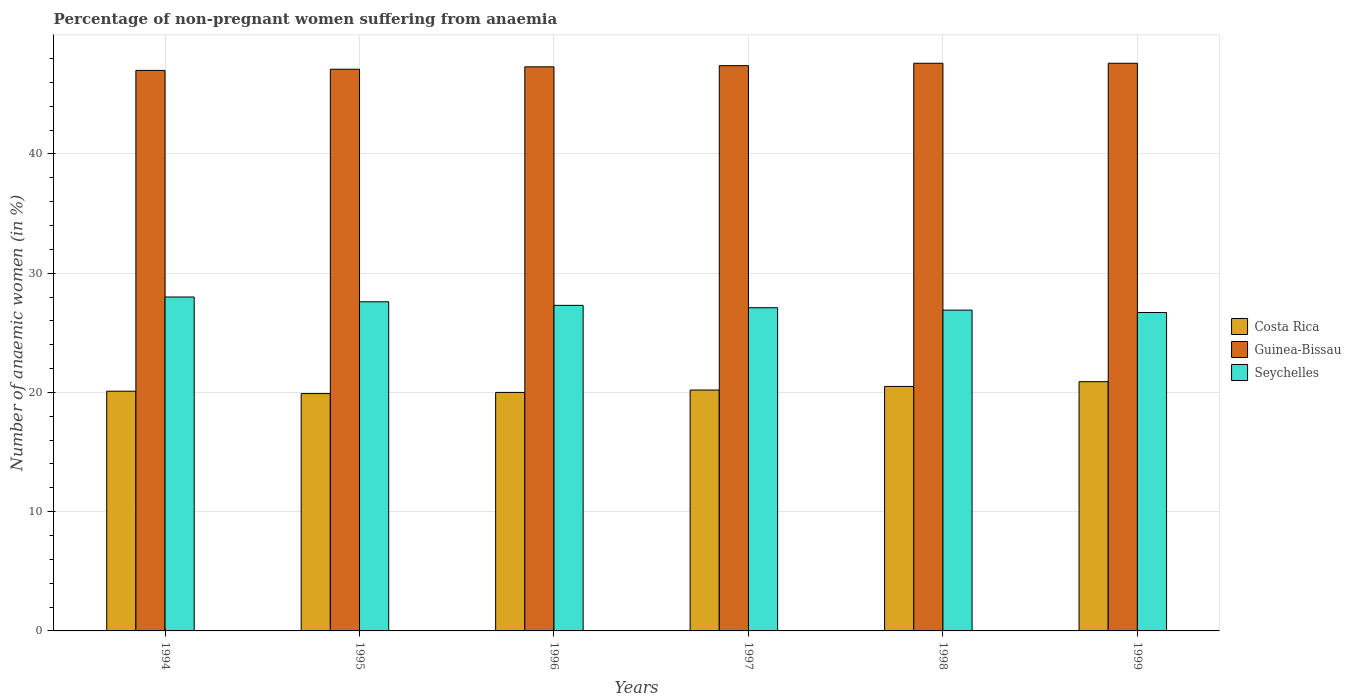How many groups of bars are there?
Provide a short and direct response. 6. Are the number of bars per tick equal to the number of legend labels?
Your answer should be compact. Yes. Are the number of bars on each tick of the X-axis equal?
Make the answer very short. Yes. How many bars are there on the 1st tick from the right?
Offer a terse response. 3. In how many cases, is the number of bars for a given year not equal to the number of legend labels?
Your answer should be very brief. 0. What is the percentage of non-pregnant women suffering from anaemia in Guinea-Bissau in 1997?
Your answer should be very brief. 47.4. Across all years, what is the maximum percentage of non-pregnant women suffering from anaemia in Costa Rica?
Offer a terse response. 20.9. Across all years, what is the minimum percentage of non-pregnant women suffering from anaemia in Seychelles?
Your answer should be very brief. 26.7. What is the total percentage of non-pregnant women suffering from anaemia in Guinea-Bissau in the graph?
Offer a very short reply. 284. What is the difference between the percentage of non-pregnant women suffering from anaemia in Costa Rica in 1999 and the percentage of non-pregnant women suffering from anaemia in Guinea-Bissau in 1996?
Make the answer very short. -26.4. What is the average percentage of non-pregnant women suffering from anaemia in Guinea-Bissau per year?
Make the answer very short. 47.33. In the year 1997, what is the difference between the percentage of non-pregnant women suffering from anaemia in Seychelles and percentage of non-pregnant women suffering from anaemia in Guinea-Bissau?
Provide a short and direct response. -20.3. What is the ratio of the percentage of non-pregnant women suffering from anaemia in Guinea-Bissau in 1996 to that in 1999?
Offer a terse response. 0.99. Is the percentage of non-pregnant women suffering from anaemia in Seychelles in 1995 less than that in 1998?
Your response must be concise. No. Is the difference between the percentage of non-pregnant women suffering from anaemia in Seychelles in 1995 and 1999 greater than the difference between the percentage of non-pregnant women suffering from anaemia in Guinea-Bissau in 1995 and 1999?
Provide a short and direct response. Yes. What is the difference between the highest and the lowest percentage of non-pregnant women suffering from anaemia in Costa Rica?
Offer a very short reply. 1. What does the 3rd bar from the left in 1999 represents?
Provide a succinct answer. Seychelles. What does the 2nd bar from the right in 1995 represents?
Make the answer very short. Guinea-Bissau. How many bars are there?
Make the answer very short. 18. Are the values on the major ticks of Y-axis written in scientific E-notation?
Provide a short and direct response. No. How are the legend labels stacked?
Your answer should be very brief. Vertical. What is the title of the graph?
Provide a short and direct response. Percentage of non-pregnant women suffering from anaemia. What is the label or title of the X-axis?
Keep it short and to the point. Years. What is the label or title of the Y-axis?
Provide a short and direct response. Number of anaemic women (in %). What is the Number of anaemic women (in %) of Costa Rica in 1994?
Your answer should be compact. 20.1. What is the Number of anaemic women (in %) in Guinea-Bissau in 1994?
Your answer should be compact. 47. What is the Number of anaemic women (in %) of Seychelles in 1994?
Your response must be concise. 28. What is the Number of anaemic women (in %) of Guinea-Bissau in 1995?
Provide a succinct answer. 47.1. What is the Number of anaemic women (in %) in Seychelles in 1995?
Keep it short and to the point. 27.6. What is the Number of anaemic women (in %) in Costa Rica in 1996?
Keep it short and to the point. 20. What is the Number of anaemic women (in %) of Guinea-Bissau in 1996?
Give a very brief answer. 47.3. What is the Number of anaemic women (in %) in Seychelles in 1996?
Make the answer very short. 27.3. What is the Number of anaemic women (in %) of Costa Rica in 1997?
Keep it short and to the point. 20.2. What is the Number of anaemic women (in %) of Guinea-Bissau in 1997?
Give a very brief answer. 47.4. What is the Number of anaemic women (in %) of Seychelles in 1997?
Your response must be concise. 27.1. What is the Number of anaemic women (in %) in Costa Rica in 1998?
Your answer should be very brief. 20.5. What is the Number of anaemic women (in %) of Guinea-Bissau in 1998?
Offer a terse response. 47.6. What is the Number of anaemic women (in %) of Seychelles in 1998?
Your answer should be compact. 26.9. What is the Number of anaemic women (in %) in Costa Rica in 1999?
Your response must be concise. 20.9. What is the Number of anaemic women (in %) in Guinea-Bissau in 1999?
Ensure brevity in your answer.  47.6. What is the Number of anaemic women (in %) of Seychelles in 1999?
Your answer should be compact. 26.7. Across all years, what is the maximum Number of anaemic women (in %) in Costa Rica?
Offer a terse response. 20.9. Across all years, what is the maximum Number of anaemic women (in %) in Guinea-Bissau?
Offer a very short reply. 47.6. Across all years, what is the minimum Number of anaemic women (in %) of Guinea-Bissau?
Provide a succinct answer. 47. Across all years, what is the minimum Number of anaemic women (in %) of Seychelles?
Give a very brief answer. 26.7. What is the total Number of anaemic women (in %) in Costa Rica in the graph?
Give a very brief answer. 121.6. What is the total Number of anaemic women (in %) of Guinea-Bissau in the graph?
Your response must be concise. 284. What is the total Number of anaemic women (in %) in Seychelles in the graph?
Your response must be concise. 163.6. What is the difference between the Number of anaemic women (in %) in Guinea-Bissau in 1994 and that in 1995?
Your answer should be compact. -0.1. What is the difference between the Number of anaemic women (in %) in Seychelles in 1994 and that in 1995?
Your response must be concise. 0.4. What is the difference between the Number of anaemic women (in %) in Costa Rica in 1994 and that in 1996?
Offer a very short reply. 0.1. What is the difference between the Number of anaemic women (in %) in Seychelles in 1994 and that in 1997?
Offer a terse response. 0.9. What is the difference between the Number of anaemic women (in %) in Costa Rica in 1994 and that in 1999?
Your response must be concise. -0.8. What is the difference between the Number of anaemic women (in %) in Guinea-Bissau in 1994 and that in 1999?
Give a very brief answer. -0.6. What is the difference between the Number of anaemic women (in %) of Costa Rica in 1995 and that in 1996?
Keep it short and to the point. -0.1. What is the difference between the Number of anaemic women (in %) of Guinea-Bissau in 1995 and that in 1996?
Your response must be concise. -0.2. What is the difference between the Number of anaemic women (in %) in Costa Rica in 1995 and that in 1997?
Your answer should be compact. -0.3. What is the difference between the Number of anaemic women (in %) in Guinea-Bissau in 1995 and that in 1997?
Offer a very short reply. -0.3. What is the difference between the Number of anaemic women (in %) of Seychelles in 1995 and that in 1997?
Offer a terse response. 0.5. What is the difference between the Number of anaemic women (in %) in Guinea-Bissau in 1995 and that in 1998?
Keep it short and to the point. -0.5. What is the difference between the Number of anaemic women (in %) in Costa Rica in 1995 and that in 1999?
Provide a succinct answer. -1. What is the difference between the Number of anaemic women (in %) in Guinea-Bissau in 1995 and that in 1999?
Provide a succinct answer. -0.5. What is the difference between the Number of anaemic women (in %) in Guinea-Bissau in 1996 and that in 1997?
Offer a very short reply. -0.1. What is the difference between the Number of anaemic women (in %) in Guinea-Bissau in 1996 and that in 1998?
Offer a very short reply. -0.3. What is the difference between the Number of anaemic women (in %) of Seychelles in 1996 and that in 1998?
Your answer should be very brief. 0.4. What is the difference between the Number of anaemic women (in %) of Seychelles in 1996 and that in 1999?
Provide a short and direct response. 0.6. What is the difference between the Number of anaemic women (in %) of Costa Rica in 1997 and that in 1998?
Provide a short and direct response. -0.3. What is the difference between the Number of anaemic women (in %) of Guinea-Bissau in 1997 and that in 1998?
Offer a terse response. -0.2. What is the difference between the Number of anaemic women (in %) of Seychelles in 1997 and that in 1998?
Keep it short and to the point. 0.2. What is the difference between the Number of anaemic women (in %) of Costa Rica in 1997 and that in 1999?
Your answer should be very brief. -0.7. What is the difference between the Number of anaemic women (in %) in Seychelles in 1997 and that in 1999?
Provide a short and direct response. 0.4. What is the difference between the Number of anaemic women (in %) in Costa Rica in 1998 and that in 1999?
Make the answer very short. -0.4. What is the difference between the Number of anaemic women (in %) of Seychelles in 1998 and that in 1999?
Your answer should be compact. 0.2. What is the difference between the Number of anaemic women (in %) in Guinea-Bissau in 1994 and the Number of anaemic women (in %) in Seychelles in 1995?
Provide a short and direct response. 19.4. What is the difference between the Number of anaemic women (in %) of Costa Rica in 1994 and the Number of anaemic women (in %) of Guinea-Bissau in 1996?
Provide a succinct answer. -27.2. What is the difference between the Number of anaemic women (in %) in Costa Rica in 1994 and the Number of anaemic women (in %) in Seychelles in 1996?
Make the answer very short. -7.2. What is the difference between the Number of anaemic women (in %) in Costa Rica in 1994 and the Number of anaemic women (in %) in Guinea-Bissau in 1997?
Your response must be concise. -27.3. What is the difference between the Number of anaemic women (in %) of Costa Rica in 1994 and the Number of anaemic women (in %) of Seychelles in 1997?
Your answer should be very brief. -7. What is the difference between the Number of anaemic women (in %) of Guinea-Bissau in 1994 and the Number of anaemic women (in %) of Seychelles in 1997?
Your response must be concise. 19.9. What is the difference between the Number of anaemic women (in %) in Costa Rica in 1994 and the Number of anaemic women (in %) in Guinea-Bissau in 1998?
Your response must be concise. -27.5. What is the difference between the Number of anaemic women (in %) in Guinea-Bissau in 1994 and the Number of anaemic women (in %) in Seychelles in 1998?
Provide a succinct answer. 20.1. What is the difference between the Number of anaemic women (in %) of Costa Rica in 1994 and the Number of anaemic women (in %) of Guinea-Bissau in 1999?
Offer a terse response. -27.5. What is the difference between the Number of anaemic women (in %) of Guinea-Bissau in 1994 and the Number of anaemic women (in %) of Seychelles in 1999?
Give a very brief answer. 20.3. What is the difference between the Number of anaemic women (in %) of Costa Rica in 1995 and the Number of anaemic women (in %) of Guinea-Bissau in 1996?
Offer a very short reply. -27.4. What is the difference between the Number of anaemic women (in %) of Guinea-Bissau in 1995 and the Number of anaemic women (in %) of Seychelles in 1996?
Your response must be concise. 19.8. What is the difference between the Number of anaemic women (in %) in Costa Rica in 1995 and the Number of anaemic women (in %) in Guinea-Bissau in 1997?
Your answer should be very brief. -27.5. What is the difference between the Number of anaemic women (in %) in Costa Rica in 1995 and the Number of anaemic women (in %) in Guinea-Bissau in 1998?
Keep it short and to the point. -27.7. What is the difference between the Number of anaemic women (in %) in Guinea-Bissau in 1995 and the Number of anaemic women (in %) in Seychelles in 1998?
Provide a short and direct response. 20.2. What is the difference between the Number of anaemic women (in %) in Costa Rica in 1995 and the Number of anaemic women (in %) in Guinea-Bissau in 1999?
Your answer should be very brief. -27.7. What is the difference between the Number of anaemic women (in %) in Guinea-Bissau in 1995 and the Number of anaemic women (in %) in Seychelles in 1999?
Your response must be concise. 20.4. What is the difference between the Number of anaemic women (in %) in Costa Rica in 1996 and the Number of anaemic women (in %) in Guinea-Bissau in 1997?
Provide a succinct answer. -27.4. What is the difference between the Number of anaemic women (in %) of Costa Rica in 1996 and the Number of anaemic women (in %) of Seychelles in 1997?
Make the answer very short. -7.1. What is the difference between the Number of anaemic women (in %) in Guinea-Bissau in 1996 and the Number of anaemic women (in %) in Seychelles in 1997?
Your answer should be very brief. 20.2. What is the difference between the Number of anaemic women (in %) in Costa Rica in 1996 and the Number of anaemic women (in %) in Guinea-Bissau in 1998?
Your answer should be very brief. -27.6. What is the difference between the Number of anaemic women (in %) in Costa Rica in 1996 and the Number of anaemic women (in %) in Seychelles in 1998?
Offer a very short reply. -6.9. What is the difference between the Number of anaemic women (in %) of Guinea-Bissau in 1996 and the Number of anaemic women (in %) of Seychelles in 1998?
Ensure brevity in your answer.  20.4. What is the difference between the Number of anaemic women (in %) in Costa Rica in 1996 and the Number of anaemic women (in %) in Guinea-Bissau in 1999?
Your answer should be very brief. -27.6. What is the difference between the Number of anaemic women (in %) of Costa Rica in 1996 and the Number of anaemic women (in %) of Seychelles in 1999?
Provide a succinct answer. -6.7. What is the difference between the Number of anaemic women (in %) of Guinea-Bissau in 1996 and the Number of anaemic women (in %) of Seychelles in 1999?
Your response must be concise. 20.6. What is the difference between the Number of anaemic women (in %) in Costa Rica in 1997 and the Number of anaemic women (in %) in Guinea-Bissau in 1998?
Keep it short and to the point. -27.4. What is the difference between the Number of anaemic women (in %) of Costa Rica in 1997 and the Number of anaemic women (in %) of Seychelles in 1998?
Make the answer very short. -6.7. What is the difference between the Number of anaemic women (in %) of Costa Rica in 1997 and the Number of anaemic women (in %) of Guinea-Bissau in 1999?
Offer a very short reply. -27.4. What is the difference between the Number of anaemic women (in %) in Guinea-Bissau in 1997 and the Number of anaemic women (in %) in Seychelles in 1999?
Keep it short and to the point. 20.7. What is the difference between the Number of anaemic women (in %) of Costa Rica in 1998 and the Number of anaemic women (in %) of Guinea-Bissau in 1999?
Your answer should be very brief. -27.1. What is the difference between the Number of anaemic women (in %) in Guinea-Bissau in 1998 and the Number of anaemic women (in %) in Seychelles in 1999?
Keep it short and to the point. 20.9. What is the average Number of anaemic women (in %) in Costa Rica per year?
Provide a succinct answer. 20.27. What is the average Number of anaemic women (in %) of Guinea-Bissau per year?
Give a very brief answer. 47.33. What is the average Number of anaemic women (in %) of Seychelles per year?
Provide a succinct answer. 27.27. In the year 1994, what is the difference between the Number of anaemic women (in %) of Costa Rica and Number of anaemic women (in %) of Guinea-Bissau?
Provide a succinct answer. -26.9. In the year 1995, what is the difference between the Number of anaemic women (in %) of Costa Rica and Number of anaemic women (in %) of Guinea-Bissau?
Keep it short and to the point. -27.2. In the year 1996, what is the difference between the Number of anaemic women (in %) in Costa Rica and Number of anaemic women (in %) in Guinea-Bissau?
Ensure brevity in your answer.  -27.3. In the year 1997, what is the difference between the Number of anaemic women (in %) of Costa Rica and Number of anaemic women (in %) of Guinea-Bissau?
Provide a succinct answer. -27.2. In the year 1997, what is the difference between the Number of anaemic women (in %) of Guinea-Bissau and Number of anaemic women (in %) of Seychelles?
Keep it short and to the point. 20.3. In the year 1998, what is the difference between the Number of anaemic women (in %) of Costa Rica and Number of anaemic women (in %) of Guinea-Bissau?
Your answer should be compact. -27.1. In the year 1998, what is the difference between the Number of anaemic women (in %) in Guinea-Bissau and Number of anaemic women (in %) in Seychelles?
Ensure brevity in your answer.  20.7. In the year 1999, what is the difference between the Number of anaemic women (in %) in Costa Rica and Number of anaemic women (in %) in Guinea-Bissau?
Make the answer very short. -26.7. In the year 1999, what is the difference between the Number of anaemic women (in %) of Costa Rica and Number of anaemic women (in %) of Seychelles?
Your answer should be very brief. -5.8. In the year 1999, what is the difference between the Number of anaemic women (in %) of Guinea-Bissau and Number of anaemic women (in %) of Seychelles?
Give a very brief answer. 20.9. What is the ratio of the Number of anaemic women (in %) of Guinea-Bissau in 1994 to that in 1995?
Your response must be concise. 1. What is the ratio of the Number of anaemic women (in %) of Seychelles in 1994 to that in 1995?
Offer a very short reply. 1.01. What is the ratio of the Number of anaemic women (in %) of Costa Rica in 1994 to that in 1996?
Provide a short and direct response. 1. What is the ratio of the Number of anaemic women (in %) of Seychelles in 1994 to that in 1996?
Ensure brevity in your answer.  1.03. What is the ratio of the Number of anaemic women (in %) of Seychelles in 1994 to that in 1997?
Make the answer very short. 1.03. What is the ratio of the Number of anaemic women (in %) of Costa Rica in 1994 to that in 1998?
Offer a very short reply. 0.98. What is the ratio of the Number of anaemic women (in %) in Guinea-Bissau in 1994 to that in 1998?
Provide a succinct answer. 0.99. What is the ratio of the Number of anaemic women (in %) of Seychelles in 1994 to that in 1998?
Provide a succinct answer. 1.04. What is the ratio of the Number of anaemic women (in %) of Costa Rica in 1994 to that in 1999?
Your response must be concise. 0.96. What is the ratio of the Number of anaemic women (in %) in Guinea-Bissau in 1994 to that in 1999?
Make the answer very short. 0.99. What is the ratio of the Number of anaemic women (in %) in Seychelles in 1994 to that in 1999?
Provide a short and direct response. 1.05. What is the ratio of the Number of anaemic women (in %) in Costa Rica in 1995 to that in 1996?
Ensure brevity in your answer.  0.99. What is the ratio of the Number of anaemic women (in %) of Costa Rica in 1995 to that in 1997?
Your answer should be compact. 0.99. What is the ratio of the Number of anaemic women (in %) in Seychelles in 1995 to that in 1997?
Give a very brief answer. 1.02. What is the ratio of the Number of anaemic women (in %) of Costa Rica in 1995 to that in 1998?
Your response must be concise. 0.97. What is the ratio of the Number of anaemic women (in %) in Guinea-Bissau in 1995 to that in 1998?
Provide a succinct answer. 0.99. What is the ratio of the Number of anaemic women (in %) in Costa Rica in 1995 to that in 1999?
Your response must be concise. 0.95. What is the ratio of the Number of anaemic women (in %) in Guinea-Bissau in 1995 to that in 1999?
Provide a succinct answer. 0.99. What is the ratio of the Number of anaemic women (in %) of Seychelles in 1995 to that in 1999?
Make the answer very short. 1.03. What is the ratio of the Number of anaemic women (in %) of Costa Rica in 1996 to that in 1997?
Make the answer very short. 0.99. What is the ratio of the Number of anaemic women (in %) of Guinea-Bissau in 1996 to that in 1997?
Provide a short and direct response. 1. What is the ratio of the Number of anaemic women (in %) of Seychelles in 1996 to that in 1997?
Keep it short and to the point. 1.01. What is the ratio of the Number of anaemic women (in %) in Costa Rica in 1996 to that in 1998?
Give a very brief answer. 0.98. What is the ratio of the Number of anaemic women (in %) in Seychelles in 1996 to that in 1998?
Offer a very short reply. 1.01. What is the ratio of the Number of anaemic women (in %) of Costa Rica in 1996 to that in 1999?
Offer a very short reply. 0.96. What is the ratio of the Number of anaemic women (in %) of Guinea-Bissau in 1996 to that in 1999?
Make the answer very short. 0.99. What is the ratio of the Number of anaemic women (in %) in Seychelles in 1996 to that in 1999?
Ensure brevity in your answer.  1.02. What is the ratio of the Number of anaemic women (in %) of Costa Rica in 1997 to that in 1998?
Your answer should be compact. 0.99. What is the ratio of the Number of anaemic women (in %) of Seychelles in 1997 to that in 1998?
Your answer should be very brief. 1.01. What is the ratio of the Number of anaemic women (in %) in Costa Rica in 1997 to that in 1999?
Provide a succinct answer. 0.97. What is the ratio of the Number of anaemic women (in %) of Costa Rica in 1998 to that in 1999?
Your response must be concise. 0.98. What is the ratio of the Number of anaemic women (in %) of Guinea-Bissau in 1998 to that in 1999?
Offer a very short reply. 1. What is the ratio of the Number of anaemic women (in %) of Seychelles in 1998 to that in 1999?
Ensure brevity in your answer.  1.01. What is the difference between the highest and the second highest Number of anaemic women (in %) of Seychelles?
Your response must be concise. 0.4. What is the difference between the highest and the lowest Number of anaemic women (in %) of Guinea-Bissau?
Provide a short and direct response. 0.6. 